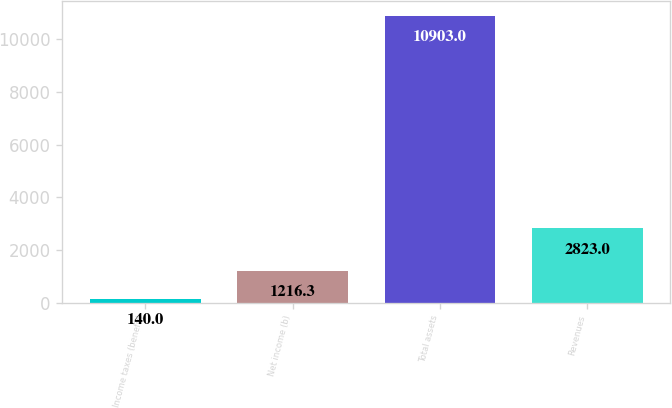<chart> <loc_0><loc_0><loc_500><loc_500><bar_chart><fcel>Income taxes (benefit)<fcel>Net income (b)<fcel>Total assets<fcel>Revenues<nl><fcel>140<fcel>1216.3<fcel>10903<fcel>2823<nl></chart> 